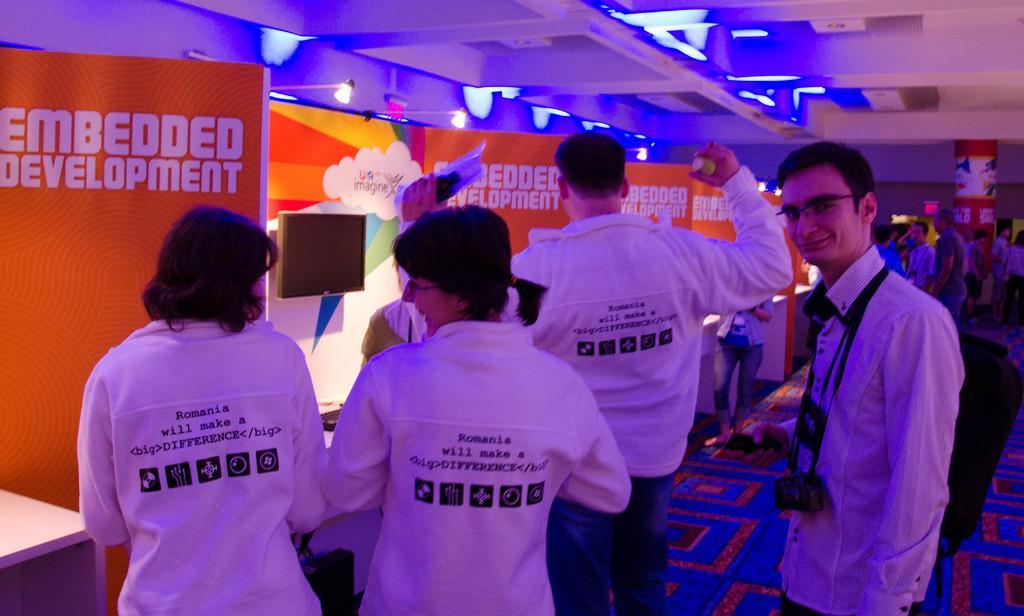Can you describe this image briefly? In this image we can see people standing on the floor, advertisement boards and electric lights. 